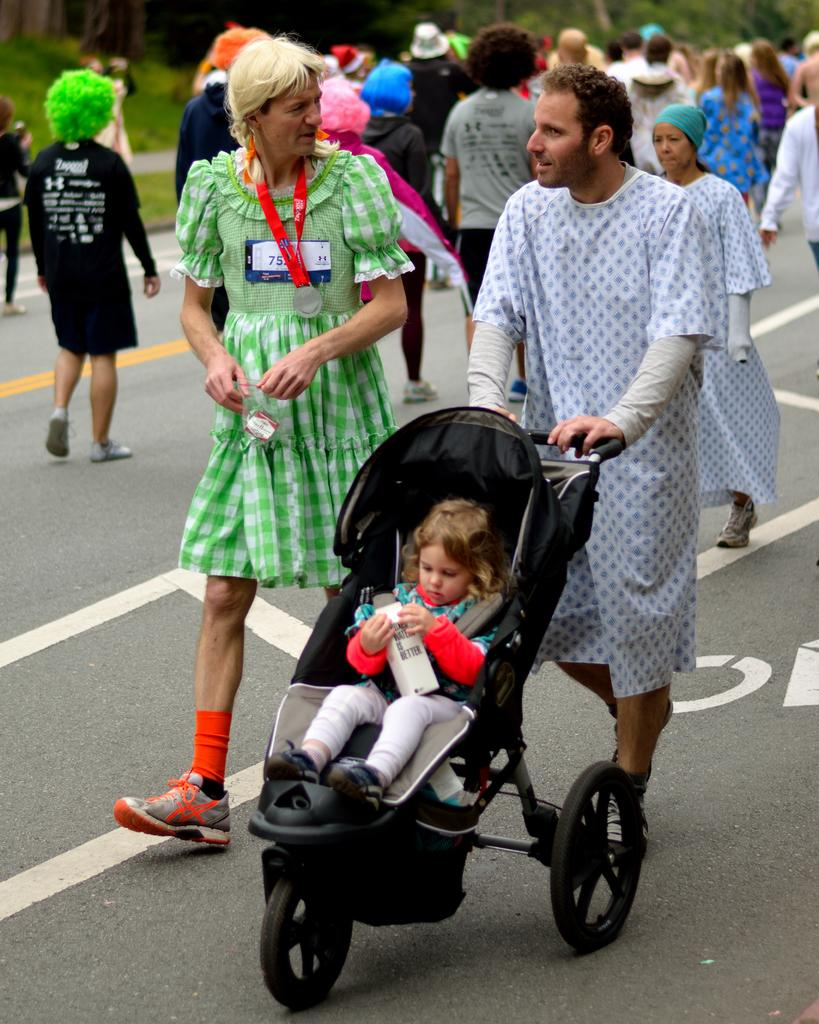What is happening on the road in the image? There is a group of people on the road in the image. Can you describe the baby in the image? The baby is in a stroller in the image. What type of vegetation can be seen in the background? There are trees in the background of the image. What else can be seen in the background? There is grass visible in the background. How does the baby use its hand to help the group of people on the road? There is no indication in the image that the baby is using its hand to help the group of people, as the baby is in a stroller. 